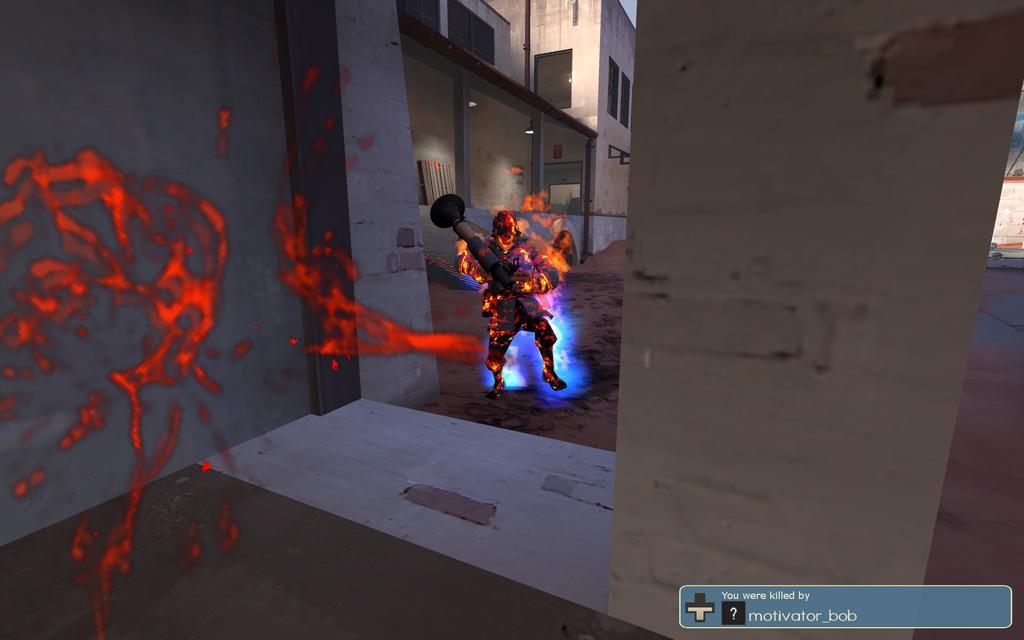Describe this image in one or two sentences. In this image I can see the animated image of the person which is in red and black color and the person holding the pole. I can see the red color mask in the front. In the back I can see the lights and the building. 